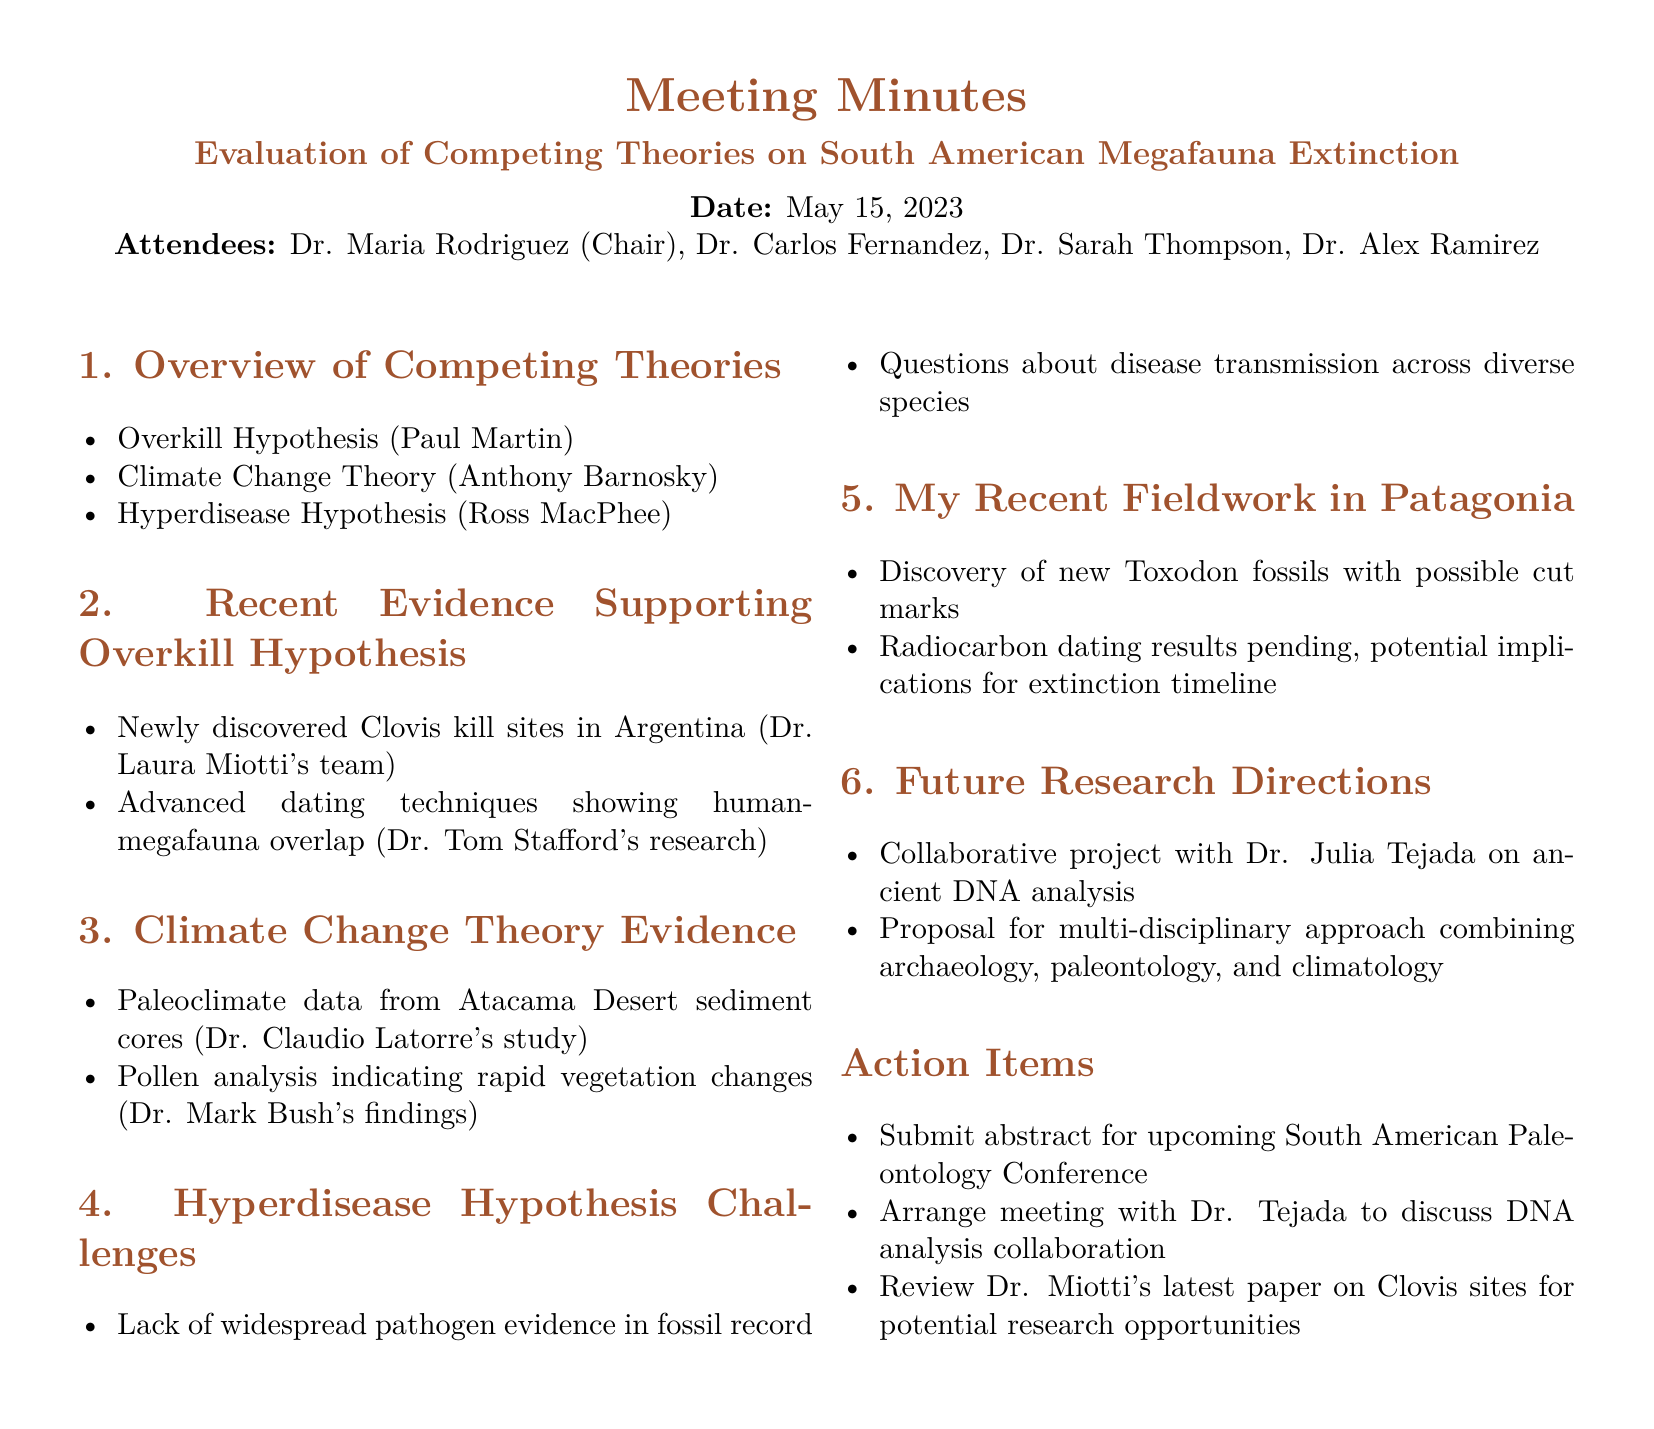What is the date of the meeting? The date of the meeting is explicitly mentioned in the document under “Date.”
Answer: May 15, 2023 Who chaired the meeting? The chair of the meeting is listed among the attendees, specifically mentioned at the beginning of the document.
Answer: Dr. Maria Rodriguez Which hypothesis is supported by newly discovered Clovis kill sites? The document states that evidence supporting one of the hypotheses is based on newly discovered Clovis kill sites, specifically mentioning who is involved.
Answer: Overkill Hypothesis What study provides paleoclimate data related to the Climate Change Theory? The document lists the relevant study that provides paleoclimate data in connection to the Climate Change Theory under its supporting evidence section.
Answer: Dr. Claudio Latorre's study What challenges does the Hyperdisease Hypothesis face? The document outlines specific challenges related to the Hyperdisease Hypothesis, covering two main points.
Answer: Lack of widespread pathogen evidence in fossil record Who is collaborating on the ancient DNA analysis project? The future research directions section mentions specific individuals collaborating on a project, including one named in the document.
Answer: Dr. Julia Tejada What type of approach is proposed for future research? The document outlines a proposed method for future research under a specific section that suggests combining different fields.
Answer: Multi-disciplinary approach How many attendees were present at the meeting? The attendees are listed at the start of the document, with their names included in a specific format.
Answer: Four What is pending regarding the recent fieldwork in Patagonia? The document notes a specific pending action related to the recent discoveries made during fieldwork, related to dating techniques.
Answer: Radiocarbon dating results pending 